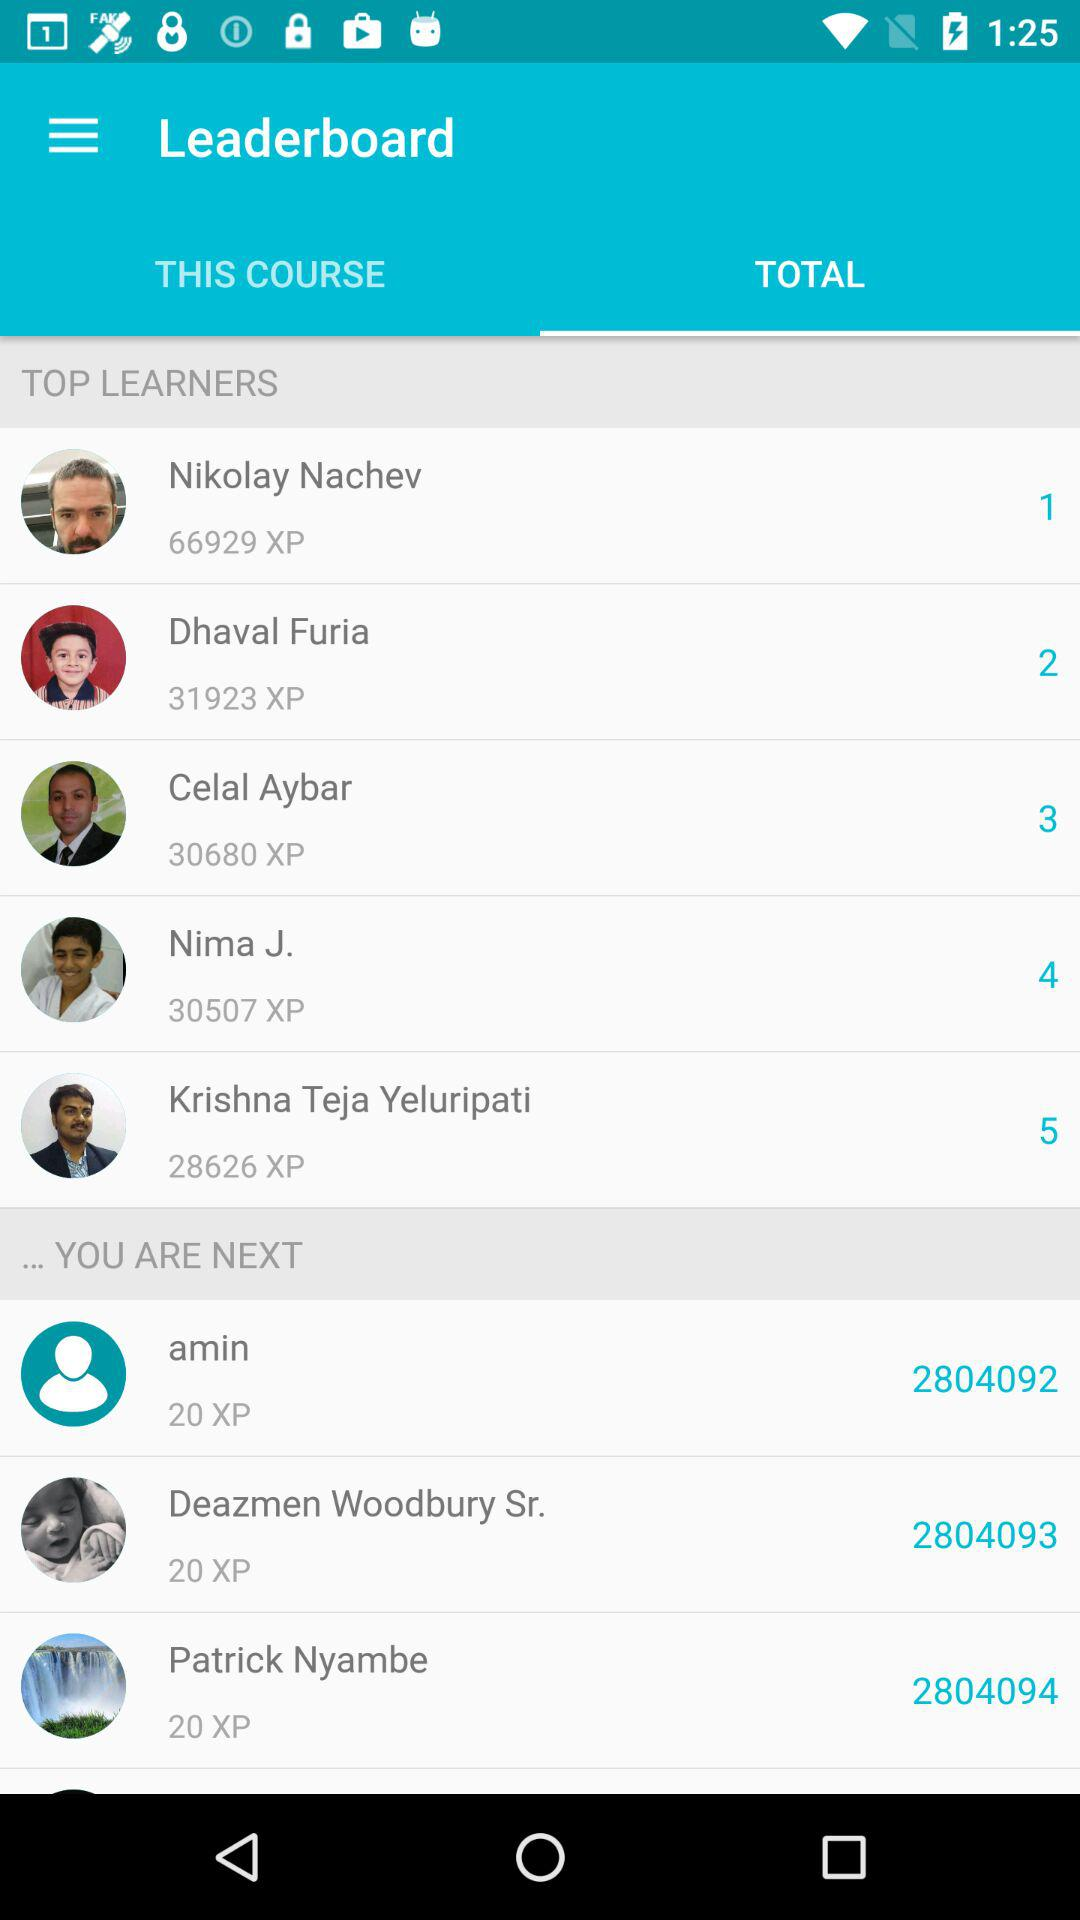How many people have 20 XP or less?
Answer the question using a single word or phrase. 3 